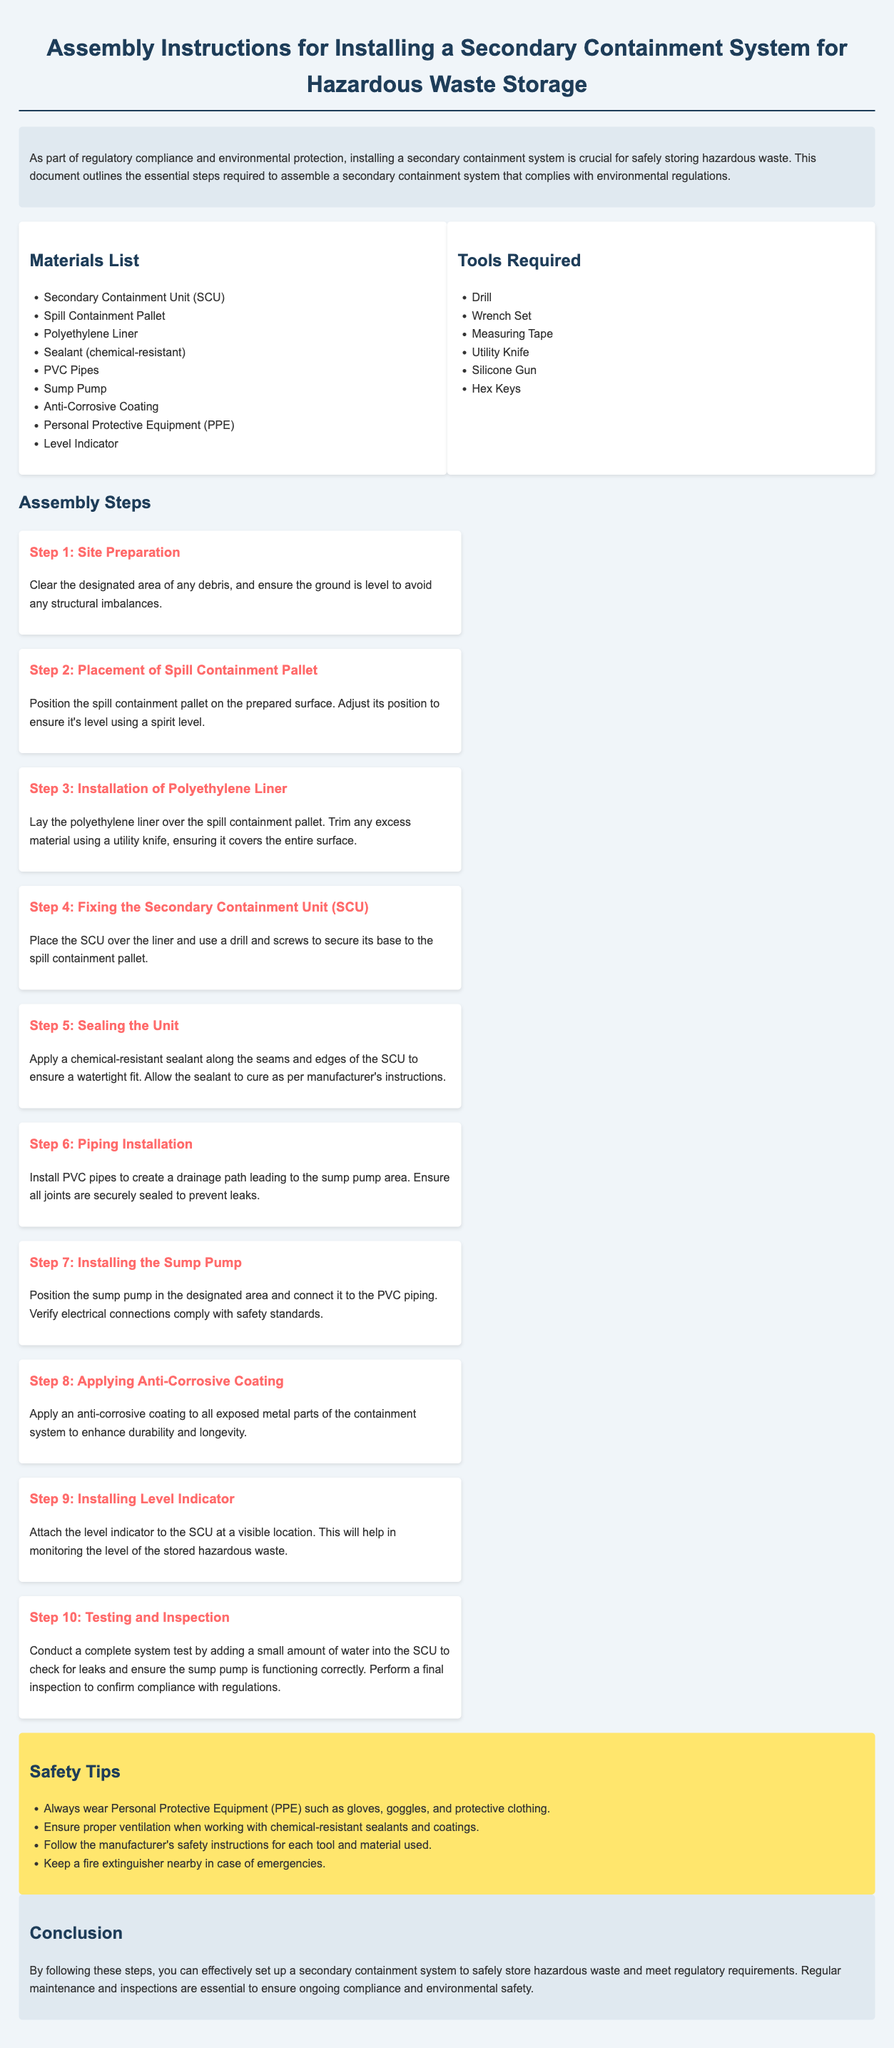What is the title of the document? The title of the document is provided at the top of the body section.
Answer: Assembly Instructions for Installing a Secondary Containment System for Hazardous Waste Storage What is the primary purpose of the secondary containment system? The purpose is mentioned in the introduction section, focusing on regulatory compliance and environmental protection.
Answer: Safely storing hazardous waste How many steps are outlined for the installation process? The total steps are listed under the assembly steps section.
Answer: Ten What type of sealant is recommended? The sealant required is detailed in the sealing step of the assembly instructions.
Answer: Chemical-resistant What should you apply to enhance durability? This information is found in Step 8, which discusses the coating applied to parts of the system.
Answer: Anti-Corrosive Coating What equipment is necessary for cutting? The specific tool required for cutting is listed among the tools required for assembly.
Answer: Utility Knife Which personal protective equipment is mentioned? This detail is outlined in the safety tips section regarding PPE requirements.
Answer: Gloves, goggles, protective clothing What is the final step before concluding the process? This information is provided in Step 10, detailing the actions taken before finishing the installation process.
Answer: Testing and Inspection Where should the level indicator be attached? The location for the installation of the level indicator is referenced in Step 9.
Answer: Visible location on the SCU What should be done with the sealant after application? Instructions for the sealant are given in Step 5 regarding curing time.
Answer: Allow to cure as per manufacturer's instructions 